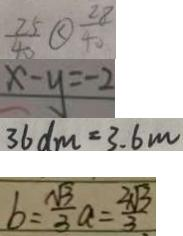Convert formula to latex. <formula><loc_0><loc_0><loc_500><loc_500>\frac { 2 5 } { 4 0 } \textcircled { < } \frac { 2 8 } { 4 0 } 
 x - y = - 2 
 3 6 d m = 3 . 6 m 
 b = \frac { \sqrt { 3 } } { 3 } a = \frac { 2 \sqrt { 3 } } { 3 }</formula> 